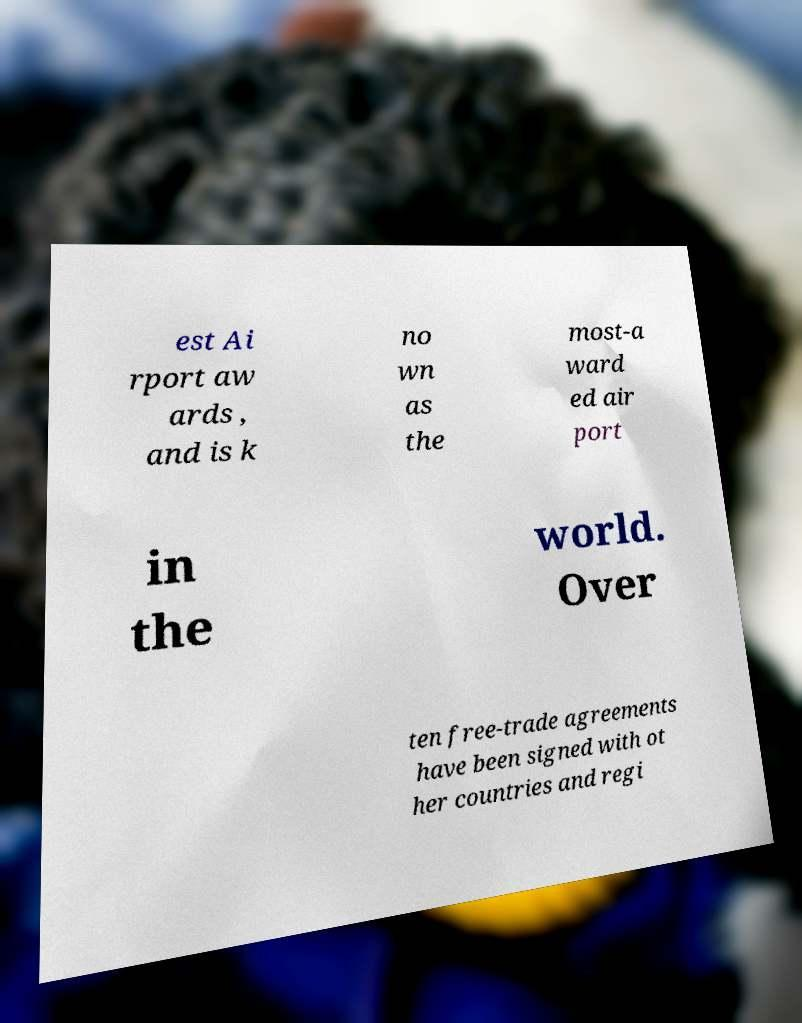Could you assist in decoding the text presented in this image and type it out clearly? est Ai rport aw ards , and is k no wn as the most-a ward ed air port in the world. Over ten free-trade agreements have been signed with ot her countries and regi 